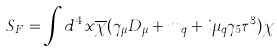<formula> <loc_0><loc_0><loc_500><loc_500>S _ { F } = \int d ^ { 4 } x \overline { \chi } ( \gamma _ { \mu } D _ { \mu } + m _ { q } + i \mu _ { q } \gamma _ { 5 } \tau ^ { 3 } ) \chi</formula> 